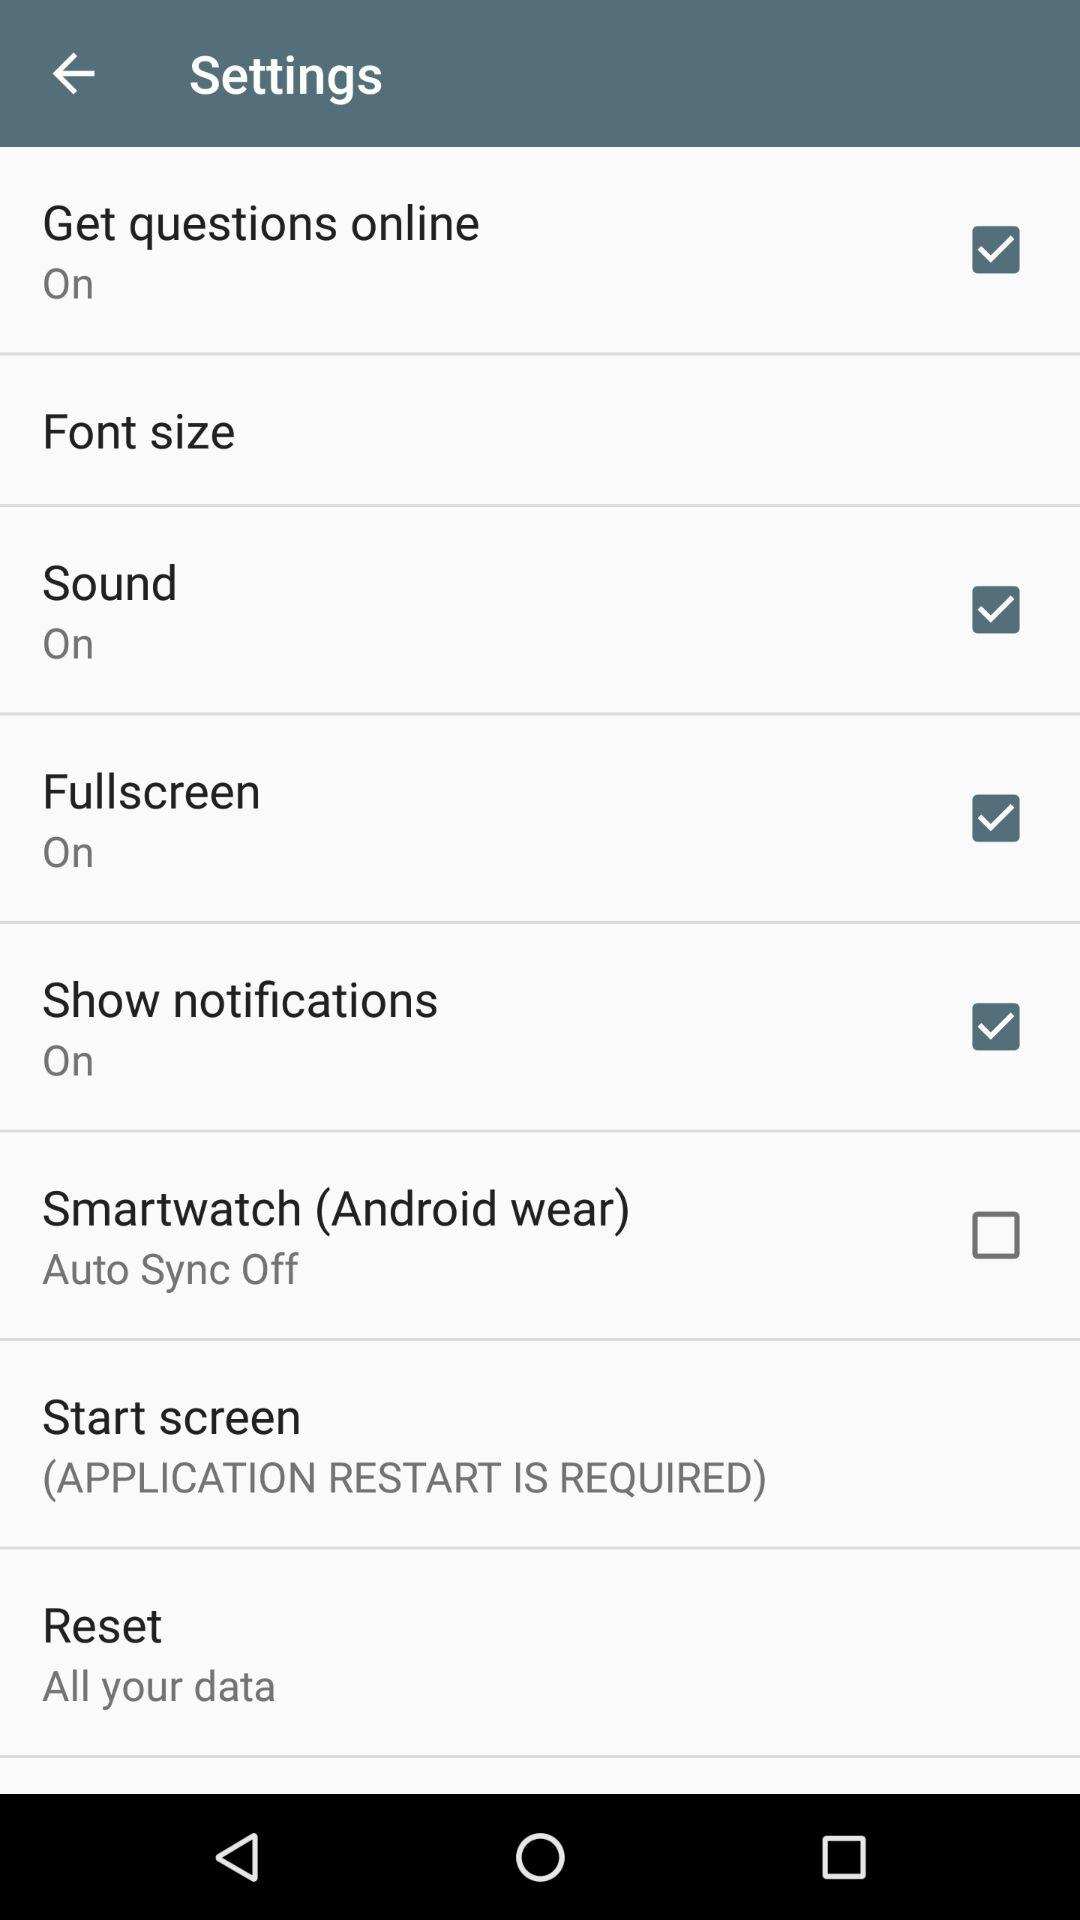What is the status of the smartwatch (Android wear)? The status is off. 